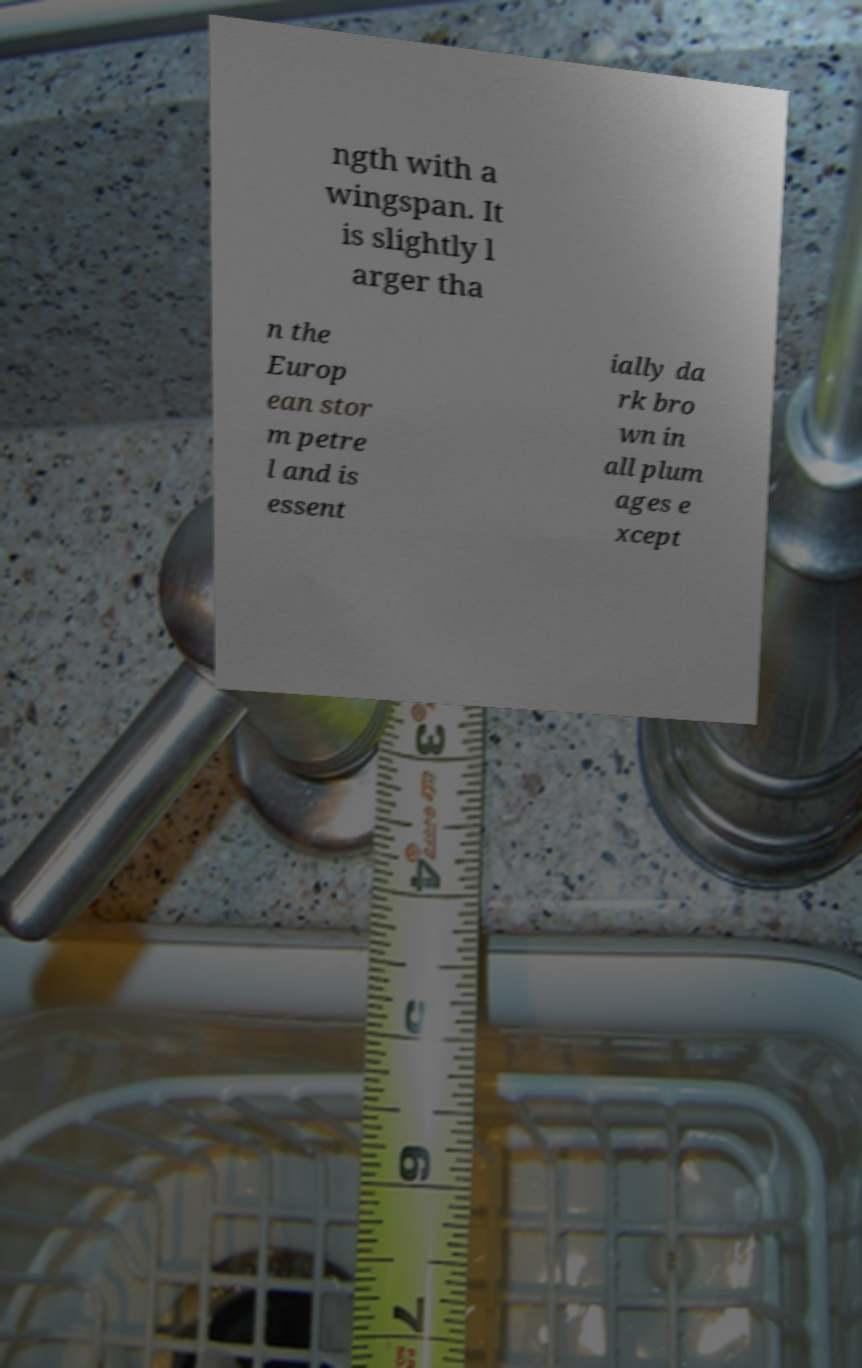Can you read and provide the text displayed in the image?This photo seems to have some interesting text. Can you extract and type it out for me? ngth with a wingspan. It is slightly l arger tha n the Europ ean stor m petre l and is essent ially da rk bro wn in all plum ages e xcept 